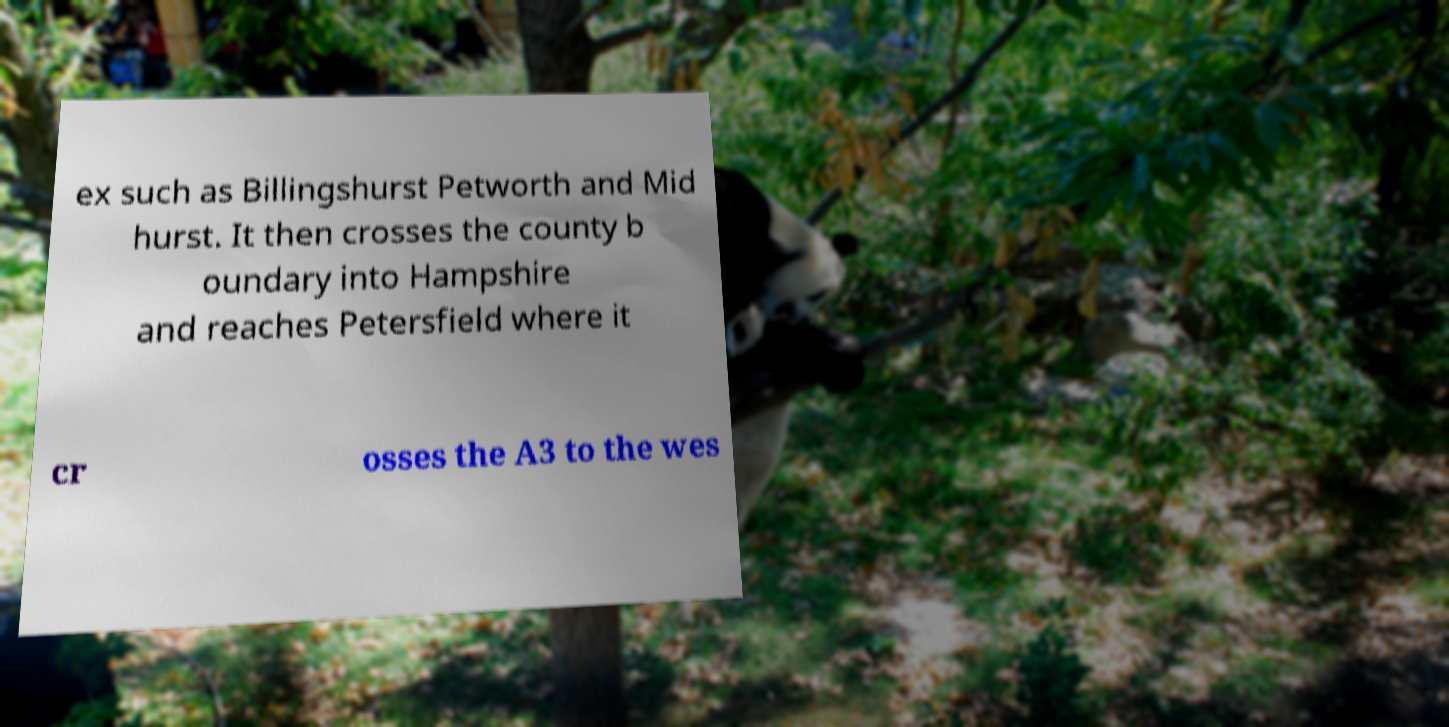Can you read and provide the text displayed in the image?This photo seems to have some interesting text. Can you extract and type it out for me? ex such as Billingshurst Petworth and Mid hurst. It then crosses the county b oundary into Hampshire and reaches Petersfield where it cr osses the A3 to the wes 